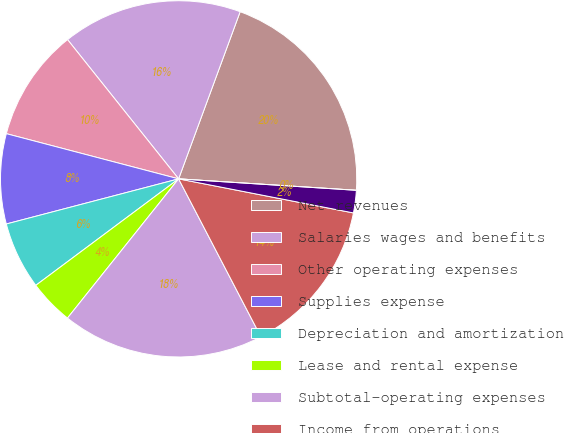Convert chart to OTSL. <chart><loc_0><loc_0><loc_500><loc_500><pie_chart><fcel>Net revenues<fcel>Salaries wages and benefits<fcel>Other operating expenses<fcel>Supplies expense<fcel>Depreciation and amortization<fcel>Lease and rental expense<fcel>Subtotal-operating expenses<fcel>Income from operations<fcel>Interest expense net<fcel>Other (income) expense net<nl><fcel>20.41%<fcel>16.33%<fcel>10.2%<fcel>8.16%<fcel>6.12%<fcel>4.08%<fcel>18.37%<fcel>14.29%<fcel>2.04%<fcel>0.0%<nl></chart> 